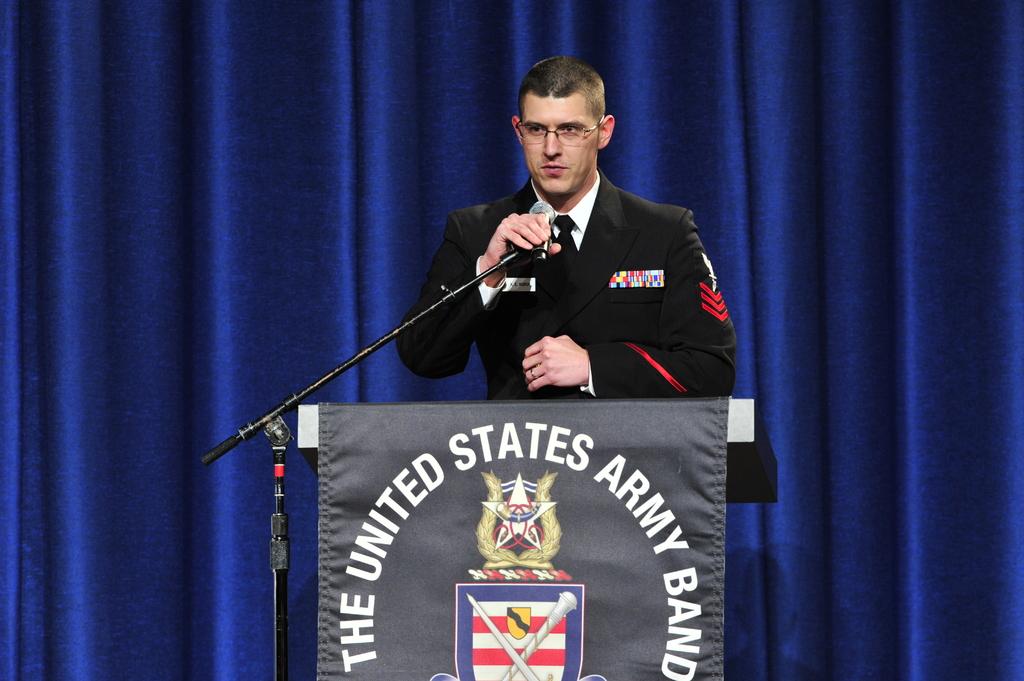What is the name of the band?
Your response must be concise. The united states army band. What branch is represented?
Your answer should be compact. Army. 